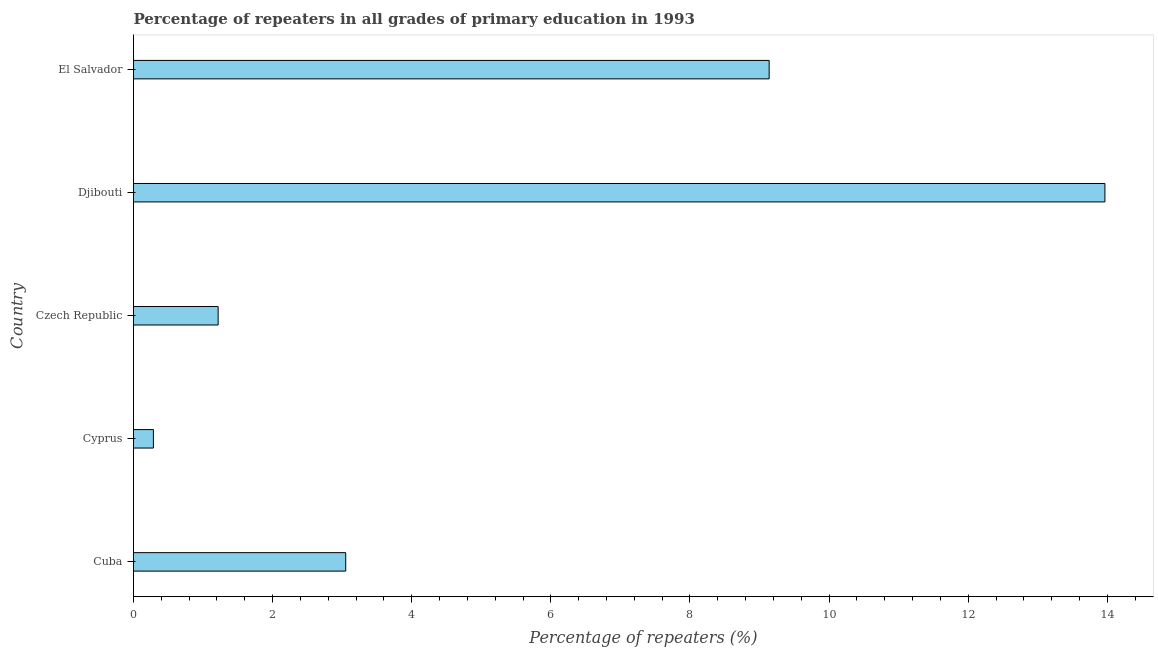Does the graph contain grids?
Ensure brevity in your answer.  No. What is the title of the graph?
Your response must be concise. Percentage of repeaters in all grades of primary education in 1993. What is the label or title of the X-axis?
Keep it short and to the point. Percentage of repeaters (%). What is the label or title of the Y-axis?
Your answer should be very brief. Country. What is the percentage of repeaters in primary education in Czech Republic?
Your answer should be compact. 1.22. Across all countries, what is the maximum percentage of repeaters in primary education?
Keep it short and to the point. 13.97. Across all countries, what is the minimum percentage of repeaters in primary education?
Give a very brief answer. 0.29. In which country was the percentage of repeaters in primary education maximum?
Your answer should be compact. Djibouti. In which country was the percentage of repeaters in primary education minimum?
Provide a short and direct response. Cyprus. What is the sum of the percentage of repeaters in primary education?
Your response must be concise. 27.66. What is the difference between the percentage of repeaters in primary education in Czech Republic and El Salvador?
Your answer should be very brief. -7.92. What is the average percentage of repeaters in primary education per country?
Provide a succinct answer. 5.53. What is the median percentage of repeaters in primary education?
Provide a succinct answer. 3.05. In how many countries, is the percentage of repeaters in primary education greater than 5.6 %?
Give a very brief answer. 2. What is the ratio of the percentage of repeaters in primary education in Cyprus to that in Czech Republic?
Make the answer very short. 0.23. What is the difference between the highest and the second highest percentage of repeaters in primary education?
Provide a succinct answer. 4.83. What is the difference between the highest and the lowest percentage of repeaters in primary education?
Offer a terse response. 13.68. How many bars are there?
Provide a succinct answer. 5. Are all the bars in the graph horizontal?
Your answer should be very brief. Yes. How many countries are there in the graph?
Give a very brief answer. 5. What is the Percentage of repeaters (%) of Cuba?
Offer a terse response. 3.05. What is the Percentage of repeaters (%) of Cyprus?
Give a very brief answer. 0.29. What is the Percentage of repeaters (%) in Czech Republic?
Offer a terse response. 1.22. What is the Percentage of repeaters (%) in Djibouti?
Your answer should be compact. 13.97. What is the Percentage of repeaters (%) in El Salvador?
Offer a terse response. 9.14. What is the difference between the Percentage of repeaters (%) in Cuba and Cyprus?
Ensure brevity in your answer.  2.76. What is the difference between the Percentage of repeaters (%) in Cuba and Czech Republic?
Provide a short and direct response. 1.83. What is the difference between the Percentage of repeaters (%) in Cuba and Djibouti?
Give a very brief answer. -10.91. What is the difference between the Percentage of repeaters (%) in Cuba and El Salvador?
Offer a very short reply. -6.09. What is the difference between the Percentage of repeaters (%) in Cyprus and Czech Republic?
Make the answer very short. -0.93. What is the difference between the Percentage of repeaters (%) in Cyprus and Djibouti?
Ensure brevity in your answer.  -13.68. What is the difference between the Percentage of repeaters (%) in Cyprus and El Salvador?
Provide a short and direct response. -8.85. What is the difference between the Percentage of repeaters (%) in Czech Republic and Djibouti?
Your response must be concise. -12.75. What is the difference between the Percentage of repeaters (%) in Czech Republic and El Salvador?
Make the answer very short. -7.92. What is the difference between the Percentage of repeaters (%) in Djibouti and El Salvador?
Offer a very short reply. 4.83. What is the ratio of the Percentage of repeaters (%) in Cuba to that in Cyprus?
Your response must be concise. 10.66. What is the ratio of the Percentage of repeaters (%) in Cuba to that in Czech Republic?
Your answer should be compact. 2.51. What is the ratio of the Percentage of repeaters (%) in Cuba to that in Djibouti?
Keep it short and to the point. 0.22. What is the ratio of the Percentage of repeaters (%) in Cuba to that in El Salvador?
Your answer should be compact. 0.33. What is the ratio of the Percentage of repeaters (%) in Cyprus to that in Czech Republic?
Give a very brief answer. 0.23. What is the ratio of the Percentage of repeaters (%) in Cyprus to that in Djibouti?
Offer a terse response. 0.02. What is the ratio of the Percentage of repeaters (%) in Cyprus to that in El Salvador?
Provide a succinct answer. 0.03. What is the ratio of the Percentage of repeaters (%) in Czech Republic to that in Djibouti?
Your response must be concise. 0.09. What is the ratio of the Percentage of repeaters (%) in Czech Republic to that in El Salvador?
Your answer should be compact. 0.13. What is the ratio of the Percentage of repeaters (%) in Djibouti to that in El Salvador?
Keep it short and to the point. 1.53. 